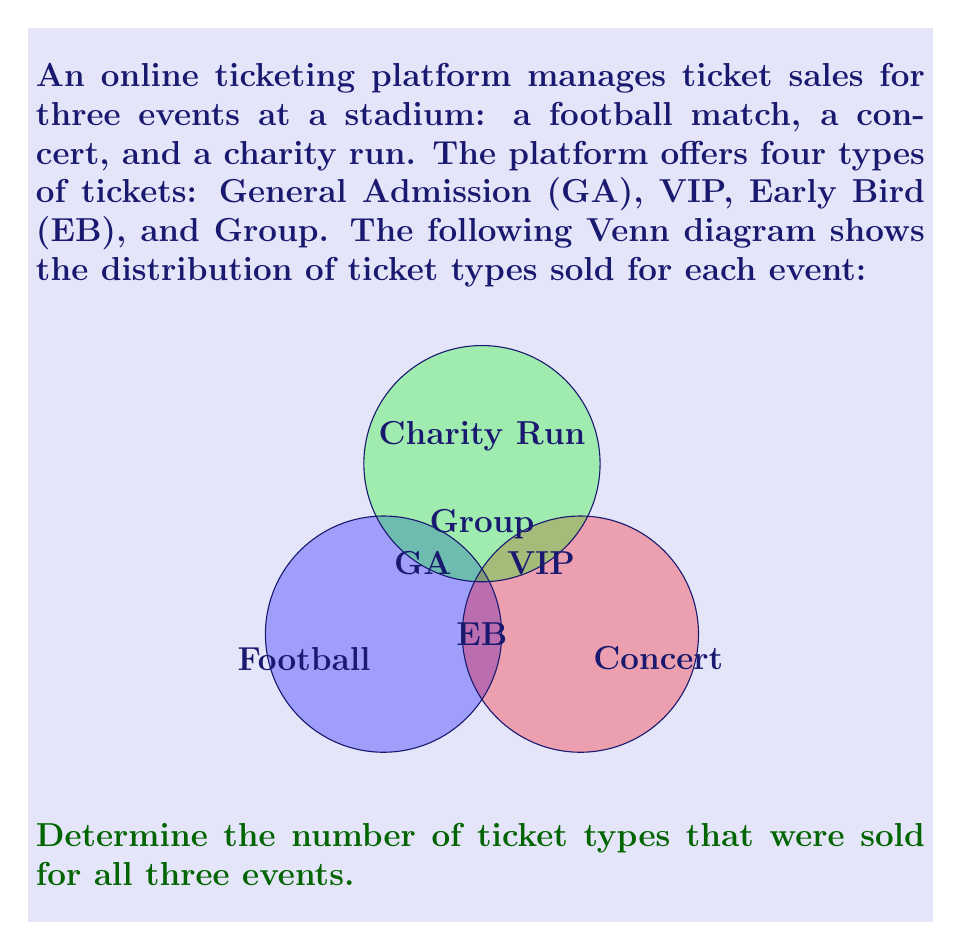Help me with this question. To solve this problem, we need to identify the intersection of all three sets (Football, Concert, and Charity Run) in the Venn diagram. This intersection represents the ticket types that were sold for all three events.

Step 1: Analyze the Venn diagram
- The diagram shows four ticket types: General Admission (GA), VIP, Early Bird (EB), and Group.
- Each circle represents an event: Football, Concert, and Charity Run.

Step 2: Identify the intersection
- Look for the region where all three circles overlap.
- In this region, we find the "Group" ticket type.

Step 3: Count the ticket types in the intersection
- There is only one ticket type (Group) in the region where all three circles overlap.

Therefore, the number of ticket types sold for all three events is 1.
Answer: 1 